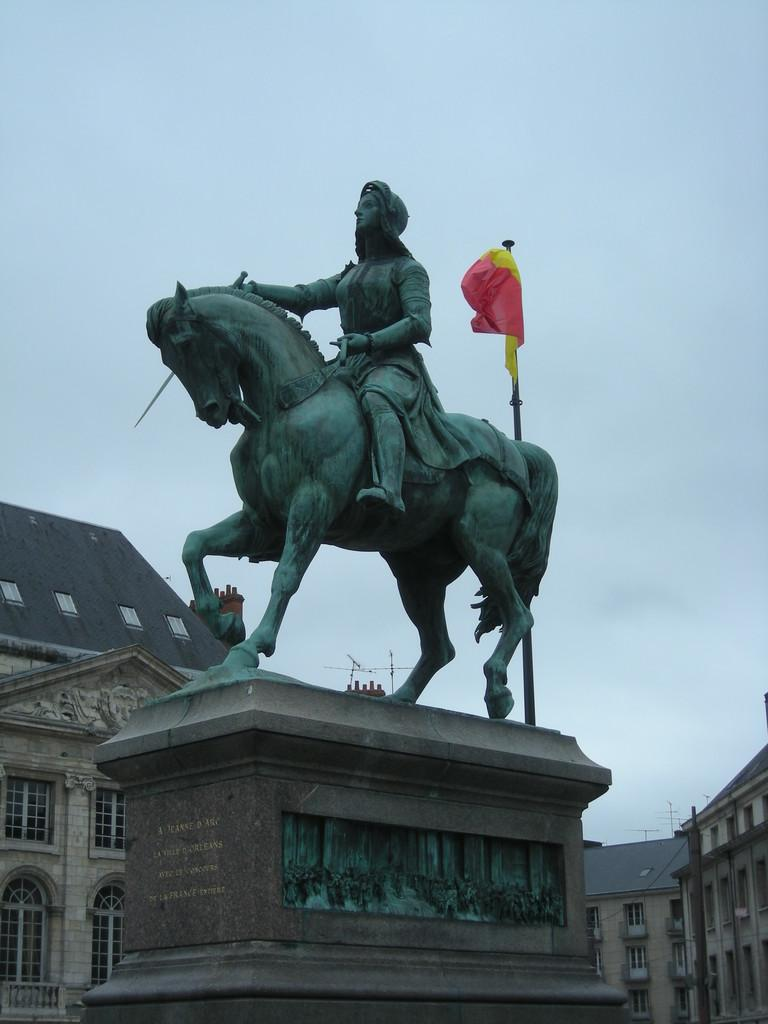What is the main subject in the image? There is a statue in the image. What else can be seen in the image besides the statue? There is a flag, a pole, a building, and clouds in the sky. What is the flag attached to in the image? The flag is attached to the pole in the image. What is the condition of the sky in the image? The sky is covered with clouds in the image. What type of basin is located near the statue in the image? There is no basin present in the image. What branch of the military is represented by the flag in the image? The image does not provide enough information to determine which branch of the military the flag represents, if any. 